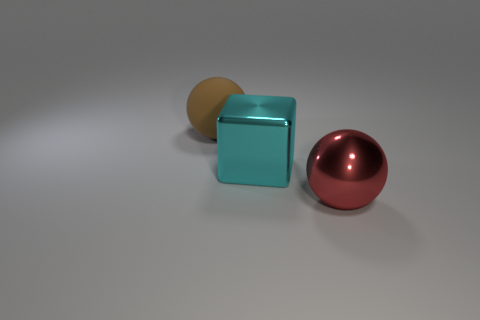How does the material of the cube compare to the materials of the other objects? The cube appears to have a matte surface, which contrasts with the two spheres that exhibit a shiny, reflective metallic finish, suggesting they are made of different materials. 